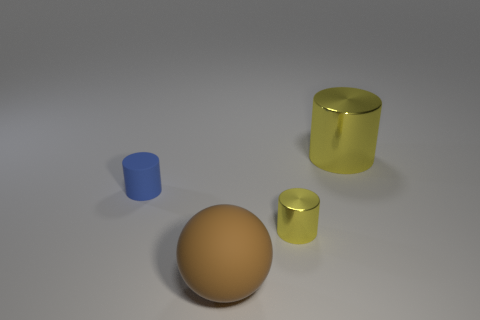The rubber cylinder has what color?
Ensure brevity in your answer.  Blue. There is a metallic cylinder that is the same size as the brown rubber ball; what is its color?
Provide a short and direct response. Yellow. Is there a tiny object of the same color as the large rubber ball?
Offer a very short reply. No. There is a tiny object that is in front of the tiny blue rubber cylinder; does it have the same shape as the rubber object that is in front of the rubber cylinder?
Offer a terse response. No. What size is the other cylinder that is the same color as the small metallic cylinder?
Ensure brevity in your answer.  Large. What number of other things are there of the same size as the brown thing?
Your response must be concise. 1. There is a small shiny cylinder; is its color the same as the thing to the left of the big sphere?
Keep it short and to the point. No. Are there fewer rubber objects that are behind the tiny blue rubber thing than small matte things that are behind the big brown matte object?
Give a very brief answer. Yes. There is a cylinder that is both right of the rubber cylinder and behind the tiny shiny object; what is its color?
Keep it short and to the point. Yellow. Is the size of the brown matte ball the same as the metal object in front of the small blue rubber thing?
Give a very brief answer. No. 